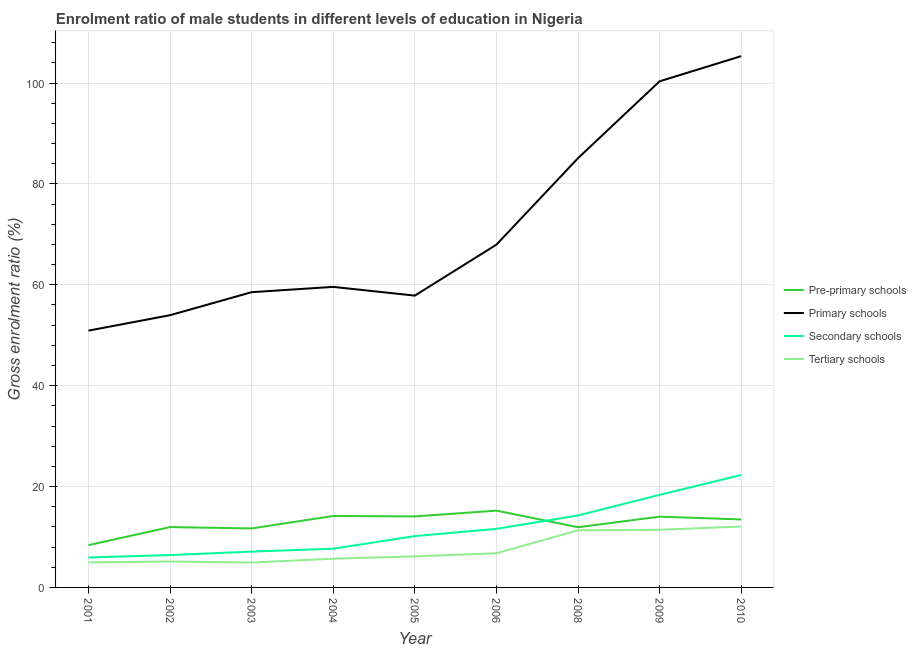Does the line corresponding to gross enrolment ratio(female) in tertiary schools intersect with the line corresponding to gross enrolment ratio(female) in secondary schools?
Make the answer very short. No. What is the gross enrolment ratio(female) in primary schools in 2005?
Offer a very short reply. 57.86. Across all years, what is the maximum gross enrolment ratio(female) in tertiary schools?
Keep it short and to the point. 12.07. Across all years, what is the minimum gross enrolment ratio(female) in primary schools?
Your answer should be compact. 50.92. In which year was the gross enrolment ratio(female) in secondary schools maximum?
Your response must be concise. 2010. In which year was the gross enrolment ratio(female) in primary schools minimum?
Provide a short and direct response. 2001. What is the total gross enrolment ratio(female) in pre-primary schools in the graph?
Offer a terse response. 114.98. What is the difference between the gross enrolment ratio(female) in tertiary schools in 2006 and that in 2008?
Provide a short and direct response. -4.55. What is the difference between the gross enrolment ratio(female) in primary schools in 2004 and the gross enrolment ratio(female) in pre-primary schools in 2009?
Keep it short and to the point. 45.55. What is the average gross enrolment ratio(female) in primary schools per year?
Your response must be concise. 71.07. In the year 2008, what is the difference between the gross enrolment ratio(female) in pre-primary schools and gross enrolment ratio(female) in tertiary schools?
Offer a terse response. 0.61. What is the ratio of the gross enrolment ratio(female) in secondary schools in 2003 to that in 2009?
Make the answer very short. 0.39. Is the difference between the gross enrolment ratio(female) in primary schools in 2002 and 2010 greater than the difference between the gross enrolment ratio(female) in pre-primary schools in 2002 and 2010?
Your answer should be compact. No. What is the difference between the highest and the second highest gross enrolment ratio(female) in primary schools?
Your answer should be very brief. 4.99. What is the difference between the highest and the lowest gross enrolment ratio(female) in primary schools?
Provide a succinct answer. 54.42. In how many years, is the gross enrolment ratio(female) in primary schools greater than the average gross enrolment ratio(female) in primary schools taken over all years?
Your response must be concise. 3. Is it the case that in every year, the sum of the gross enrolment ratio(female) in tertiary schools and gross enrolment ratio(female) in primary schools is greater than the sum of gross enrolment ratio(female) in secondary schools and gross enrolment ratio(female) in pre-primary schools?
Your answer should be very brief. Yes. Is it the case that in every year, the sum of the gross enrolment ratio(female) in pre-primary schools and gross enrolment ratio(female) in primary schools is greater than the gross enrolment ratio(female) in secondary schools?
Give a very brief answer. Yes. Does the gross enrolment ratio(female) in pre-primary schools monotonically increase over the years?
Provide a short and direct response. No. Is the gross enrolment ratio(female) in tertiary schools strictly less than the gross enrolment ratio(female) in secondary schools over the years?
Make the answer very short. Yes. What is the difference between two consecutive major ticks on the Y-axis?
Make the answer very short. 20. Does the graph contain any zero values?
Keep it short and to the point. No. What is the title of the graph?
Offer a very short reply. Enrolment ratio of male students in different levels of education in Nigeria. What is the Gross enrolment ratio (%) of Pre-primary schools in 2001?
Provide a succinct answer. 8.39. What is the Gross enrolment ratio (%) in Primary schools in 2001?
Make the answer very short. 50.92. What is the Gross enrolment ratio (%) in Secondary schools in 2001?
Provide a succinct answer. 5.94. What is the Gross enrolment ratio (%) in Tertiary schools in 2001?
Keep it short and to the point. 4.96. What is the Gross enrolment ratio (%) in Pre-primary schools in 2002?
Offer a terse response. 11.97. What is the Gross enrolment ratio (%) in Primary schools in 2002?
Keep it short and to the point. 53.98. What is the Gross enrolment ratio (%) in Secondary schools in 2002?
Give a very brief answer. 6.41. What is the Gross enrolment ratio (%) of Tertiary schools in 2002?
Provide a short and direct response. 5.14. What is the Gross enrolment ratio (%) of Pre-primary schools in 2003?
Provide a succinct answer. 11.7. What is the Gross enrolment ratio (%) of Primary schools in 2003?
Provide a short and direct response. 58.54. What is the Gross enrolment ratio (%) of Secondary schools in 2003?
Provide a succinct answer. 7.1. What is the Gross enrolment ratio (%) of Tertiary schools in 2003?
Keep it short and to the point. 4.93. What is the Gross enrolment ratio (%) of Pre-primary schools in 2004?
Your answer should be compact. 14.17. What is the Gross enrolment ratio (%) of Primary schools in 2004?
Your answer should be compact. 59.59. What is the Gross enrolment ratio (%) in Secondary schools in 2004?
Provide a succinct answer. 7.68. What is the Gross enrolment ratio (%) of Tertiary schools in 2004?
Give a very brief answer. 5.7. What is the Gross enrolment ratio (%) in Pre-primary schools in 2005?
Provide a succinct answer. 14.08. What is the Gross enrolment ratio (%) of Primary schools in 2005?
Your response must be concise. 57.86. What is the Gross enrolment ratio (%) in Secondary schools in 2005?
Offer a very short reply. 10.18. What is the Gross enrolment ratio (%) in Tertiary schools in 2005?
Keep it short and to the point. 6.16. What is the Gross enrolment ratio (%) of Pre-primary schools in 2006?
Your answer should be compact. 15.23. What is the Gross enrolment ratio (%) of Primary schools in 2006?
Provide a short and direct response. 67.96. What is the Gross enrolment ratio (%) of Secondary schools in 2006?
Ensure brevity in your answer.  11.61. What is the Gross enrolment ratio (%) of Tertiary schools in 2006?
Offer a very short reply. 6.78. What is the Gross enrolment ratio (%) of Pre-primary schools in 2008?
Your response must be concise. 11.94. What is the Gross enrolment ratio (%) of Primary schools in 2008?
Keep it short and to the point. 85.11. What is the Gross enrolment ratio (%) in Secondary schools in 2008?
Offer a terse response. 14.27. What is the Gross enrolment ratio (%) of Tertiary schools in 2008?
Provide a succinct answer. 11.32. What is the Gross enrolment ratio (%) in Pre-primary schools in 2009?
Your response must be concise. 14.04. What is the Gross enrolment ratio (%) in Primary schools in 2009?
Your response must be concise. 100.35. What is the Gross enrolment ratio (%) in Secondary schools in 2009?
Your answer should be compact. 18.35. What is the Gross enrolment ratio (%) of Tertiary schools in 2009?
Provide a short and direct response. 11.43. What is the Gross enrolment ratio (%) in Pre-primary schools in 2010?
Keep it short and to the point. 13.48. What is the Gross enrolment ratio (%) of Primary schools in 2010?
Provide a short and direct response. 105.34. What is the Gross enrolment ratio (%) of Secondary schools in 2010?
Your response must be concise. 22.3. What is the Gross enrolment ratio (%) of Tertiary schools in 2010?
Keep it short and to the point. 12.07. Across all years, what is the maximum Gross enrolment ratio (%) in Pre-primary schools?
Give a very brief answer. 15.23. Across all years, what is the maximum Gross enrolment ratio (%) of Primary schools?
Provide a short and direct response. 105.34. Across all years, what is the maximum Gross enrolment ratio (%) in Secondary schools?
Your response must be concise. 22.3. Across all years, what is the maximum Gross enrolment ratio (%) of Tertiary schools?
Give a very brief answer. 12.07. Across all years, what is the minimum Gross enrolment ratio (%) of Pre-primary schools?
Give a very brief answer. 8.39. Across all years, what is the minimum Gross enrolment ratio (%) in Primary schools?
Give a very brief answer. 50.92. Across all years, what is the minimum Gross enrolment ratio (%) of Secondary schools?
Offer a very short reply. 5.94. Across all years, what is the minimum Gross enrolment ratio (%) in Tertiary schools?
Give a very brief answer. 4.93. What is the total Gross enrolment ratio (%) of Pre-primary schools in the graph?
Your response must be concise. 114.98. What is the total Gross enrolment ratio (%) in Primary schools in the graph?
Your answer should be very brief. 639.64. What is the total Gross enrolment ratio (%) in Secondary schools in the graph?
Ensure brevity in your answer.  103.84. What is the total Gross enrolment ratio (%) of Tertiary schools in the graph?
Your answer should be compact. 68.5. What is the difference between the Gross enrolment ratio (%) of Pre-primary schools in 2001 and that in 2002?
Keep it short and to the point. -3.58. What is the difference between the Gross enrolment ratio (%) of Primary schools in 2001 and that in 2002?
Provide a succinct answer. -3.06. What is the difference between the Gross enrolment ratio (%) in Secondary schools in 2001 and that in 2002?
Keep it short and to the point. -0.48. What is the difference between the Gross enrolment ratio (%) in Tertiary schools in 2001 and that in 2002?
Provide a succinct answer. -0.18. What is the difference between the Gross enrolment ratio (%) of Pre-primary schools in 2001 and that in 2003?
Make the answer very short. -3.31. What is the difference between the Gross enrolment ratio (%) in Primary schools in 2001 and that in 2003?
Offer a terse response. -7.62. What is the difference between the Gross enrolment ratio (%) in Secondary schools in 2001 and that in 2003?
Provide a short and direct response. -1.17. What is the difference between the Gross enrolment ratio (%) in Tertiary schools in 2001 and that in 2003?
Give a very brief answer. 0.03. What is the difference between the Gross enrolment ratio (%) in Pre-primary schools in 2001 and that in 2004?
Ensure brevity in your answer.  -5.78. What is the difference between the Gross enrolment ratio (%) in Primary schools in 2001 and that in 2004?
Your answer should be compact. -8.67. What is the difference between the Gross enrolment ratio (%) in Secondary schools in 2001 and that in 2004?
Offer a very short reply. -1.74. What is the difference between the Gross enrolment ratio (%) in Tertiary schools in 2001 and that in 2004?
Provide a short and direct response. -0.73. What is the difference between the Gross enrolment ratio (%) of Pre-primary schools in 2001 and that in 2005?
Make the answer very short. -5.69. What is the difference between the Gross enrolment ratio (%) in Primary schools in 2001 and that in 2005?
Provide a succinct answer. -6.94. What is the difference between the Gross enrolment ratio (%) in Secondary schools in 2001 and that in 2005?
Your response must be concise. -4.24. What is the difference between the Gross enrolment ratio (%) of Tertiary schools in 2001 and that in 2005?
Give a very brief answer. -1.2. What is the difference between the Gross enrolment ratio (%) in Pre-primary schools in 2001 and that in 2006?
Your answer should be very brief. -6.84. What is the difference between the Gross enrolment ratio (%) in Primary schools in 2001 and that in 2006?
Make the answer very short. -17.04. What is the difference between the Gross enrolment ratio (%) of Secondary schools in 2001 and that in 2006?
Make the answer very short. -5.68. What is the difference between the Gross enrolment ratio (%) in Tertiary schools in 2001 and that in 2006?
Provide a succinct answer. -1.81. What is the difference between the Gross enrolment ratio (%) of Pre-primary schools in 2001 and that in 2008?
Give a very brief answer. -3.55. What is the difference between the Gross enrolment ratio (%) in Primary schools in 2001 and that in 2008?
Your response must be concise. -34.19. What is the difference between the Gross enrolment ratio (%) in Secondary schools in 2001 and that in 2008?
Make the answer very short. -8.33. What is the difference between the Gross enrolment ratio (%) in Tertiary schools in 2001 and that in 2008?
Your answer should be compact. -6.36. What is the difference between the Gross enrolment ratio (%) in Pre-primary schools in 2001 and that in 2009?
Your answer should be very brief. -5.65. What is the difference between the Gross enrolment ratio (%) in Primary schools in 2001 and that in 2009?
Your answer should be very brief. -49.43. What is the difference between the Gross enrolment ratio (%) in Secondary schools in 2001 and that in 2009?
Make the answer very short. -12.42. What is the difference between the Gross enrolment ratio (%) in Tertiary schools in 2001 and that in 2009?
Make the answer very short. -6.47. What is the difference between the Gross enrolment ratio (%) of Pre-primary schools in 2001 and that in 2010?
Give a very brief answer. -5.09. What is the difference between the Gross enrolment ratio (%) of Primary schools in 2001 and that in 2010?
Offer a terse response. -54.42. What is the difference between the Gross enrolment ratio (%) in Secondary schools in 2001 and that in 2010?
Your answer should be compact. -16.36. What is the difference between the Gross enrolment ratio (%) of Tertiary schools in 2001 and that in 2010?
Offer a very short reply. -7.11. What is the difference between the Gross enrolment ratio (%) of Pre-primary schools in 2002 and that in 2003?
Provide a succinct answer. 0.27. What is the difference between the Gross enrolment ratio (%) in Primary schools in 2002 and that in 2003?
Provide a short and direct response. -4.56. What is the difference between the Gross enrolment ratio (%) of Secondary schools in 2002 and that in 2003?
Provide a short and direct response. -0.69. What is the difference between the Gross enrolment ratio (%) of Tertiary schools in 2002 and that in 2003?
Provide a succinct answer. 0.21. What is the difference between the Gross enrolment ratio (%) in Pre-primary schools in 2002 and that in 2004?
Your response must be concise. -2.2. What is the difference between the Gross enrolment ratio (%) of Primary schools in 2002 and that in 2004?
Your answer should be compact. -5.61. What is the difference between the Gross enrolment ratio (%) in Secondary schools in 2002 and that in 2004?
Give a very brief answer. -1.26. What is the difference between the Gross enrolment ratio (%) of Tertiary schools in 2002 and that in 2004?
Keep it short and to the point. -0.55. What is the difference between the Gross enrolment ratio (%) in Pre-primary schools in 2002 and that in 2005?
Offer a terse response. -2.11. What is the difference between the Gross enrolment ratio (%) of Primary schools in 2002 and that in 2005?
Your response must be concise. -3.88. What is the difference between the Gross enrolment ratio (%) in Secondary schools in 2002 and that in 2005?
Keep it short and to the point. -3.77. What is the difference between the Gross enrolment ratio (%) of Tertiary schools in 2002 and that in 2005?
Offer a terse response. -1.02. What is the difference between the Gross enrolment ratio (%) in Pre-primary schools in 2002 and that in 2006?
Keep it short and to the point. -3.26. What is the difference between the Gross enrolment ratio (%) of Primary schools in 2002 and that in 2006?
Ensure brevity in your answer.  -13.98. What is the difference between the Gross enrolment ratio (%) of Secondary schools in 2002 and that in 2006?
Your answer should be very brief. -5.2. What is the difference between the Gross enrolment ratio (%) of Tertiary schools in 2002 and that in 2006?
Provide a short and direct response. -1.63. What is the difference between the Gross enrolment ratio (%) of Pre-primary schools in 2002 and that in 2008?
Make the answer very short. 0.03. What is the difference between the Gross enrolment ratio (%) of Primary schools in 2002 and that in 2008?
Provide a short and direct response. -31.13. What is the difference between the Gross enrolment ratio (%) in Secondary schools in 2002 and that in 2008?
Offer a very short reply. -7.85. What is the difference between the Gross enrolment ratio (%) in Tertiary schools in 2002 and that in 2008?
Make the answer very short. -6.18. What is the difference between the Gross enrolment ratio (%) in Pre-primary schools in 2002 and that in 2009?
Your response must be concise. -2.07. What is the difference between the Gross enrolment ratio (%) of Primary schools in 2002 and that in 2009?
Provide a short and direct response. -46.37. What is the difference between the Gross enrolment ratio (%) in Secondary schools in 2002 and that in 2009?
Your response must be concise. -11.94. What is the difference between the Gross enrolment ratio (%) of Tertiary schools in 2002 and that in 2009?
Offer a very short reply. -6.29. What is the difference between the Gross enrolment ratio (%) in Pre-primary schools in 2002 and that in 2010?
Your response must be concise. -1.51. What is the difference between the Gross enrolment ratio (%) in Primary schools in 2002 and that in 2010?
Keep it short and to the point. -51.36. What is the difference between the Gross enrolment ratio (%) in Secondary schools in 2002 and that in 2010?
Ensure brevity in your answer.  -15.88. What is the difference between the Gross enrolment ratio (%) in Tertiary schools in 2002 and that in 2010?
Provide a succinct answer. -6.93. What is the difference between the Gross enrolment ratio (%) of Pre-primary schools in 2003 and that in 2004?
Make the answer very short. -2.47. What is the difference between the Gross enrolment ratio (%) of Primary schools in 2003 and that in 2004?
Make the answer very short. -1.05. What is the difference between the Gross enrolment ratio (%) in Secondary schools in 2003 and that in 2004?
Your response must be concise. -0.57. What is the difference between the Gross enrolment ratio (%) of Tertiary schools in 2003 and that in 2004?
Your response must be concise. -0.77. What is the difference between the Gross enrolment ratio (%) of Pre-primary schools in 2003 and that in 2005?
Ensure brevity in your answer.  -2.38. What is the difference between the Gross enrolment ratio (%) in Primary schools in 2003 and that in 2005?
Provide a short and direct response. 0.68. What is the difference between the Gross enrolment ratio (%) in Secondary schools in 2003 and that in 2005?
Make the answer very short. -3.07. What is the difference between the Gross enrolment ratio (%) in Tertiary schools in 2003 and that in 2005?
Your answer should be compact. -1.23. What is the difference between the Gross enrolment ratio (%) in Pre-primary schools in 2003 and that in 2006?
Ensure brevity in your answer.  -3.53. What is the difference between the Gross enrolment ratio (%) in Primary schools in 2003 and that in 2006?
Give a very brief answer. -9.42. What is the difference between the Gross enrolment ratio (%) of Secondary schools in 2003 and that in 2006?
Offer a very short reply. -4.51. What is the difference between the Gross enrolment ratio (%) of Tertiary schools in 2003 and that in 2006?
Give a very brief answer. -1.84. What is the difference between the Gross enrolment ratio (%) of Pre-primary schools in 2003 and that in 2008?
Give a very brief answer. -0.24. What is the difference between the Gross enrolment ratio (%) in Primary schools in 2003 and that in 2008?
Your answer should be very brief. -26.57. What is the difference between the Gross enrolment ratio (%) of Secondary schools in 2003 and that in 2008?
Your answer should be very brief. -7.16. What is the difference between the Gross enrolment ratio (%) of Tertiary schools in 2003 and that in 2008?
Ensure brevity in your answer.  -6.39. What is the difference between the Gross enrolment ratio (%) of Pre-primary schools in 2003 and that in 2009?
Your answer should be compact. -2.34. What is the difference between the Gross enrolment ratio (%) in Primary schools in 2003 and that in 2009?
Your answer should be very brief. -41.81. What is the difference between the Gross enrolment ratio (%) of Secondary schools in 2003 and that in 2009?
Offer a terse response. -11.25. What is the difference between the Gross enrolment ratio (%) in Tertiary schools in 2003 and that in 2009?
Ensure brevity in your answer.  -6.5. What is the difference between the Gross enrolment ratio (%) in Pre-primary schools in 2003 and that in 2010?
Keep it short and to the point. -1.78. What is the difference between the Gross enrolment ratio (%) of Primary schools in 2003 and that in 2010?
Your answer should be very brief. -46.8. What is the difference between the Gross enrolment ratio (%) of Secondary schools in 2003 and that in 2010?
Offer a terse response. -15.19. What is the difference between the Gross enrolment ratio (%) in Tertiary schools in 2003 and that in 2010?
Give a very brief answer. -7.14. What is the difference between the Gross enrolment ratio (%) of Pre-primary schools in 2004 and that in 2005?
Provide a short and direct response. 0.09. What is the difference between the Gross enrolment ratio (%) of Primary schools in 2004 and that in 2005?
Your response must be concise. 1.73. What is the difference between the Gross enrolment ratio (%) of Secondary schools in 2004 and that in 2005?
Your answer should be very brief. -2.5. What is the difference between the Gross enrolment ratio (%) in Tertiary schools in 2004 and that in 2005?
Keep it short and to the point. -0.47. What is the difference between the Gross enrolment ratio (%) in Pre-primary schools in 2004 and that in 2006?
Keep it short and to the point. -1.06. What is the difference between the Gross enrolment ratio (%) of Primary schools in 2004 and that in 2006?
Give a very brief answer. -8.37. What is the difference between the Gross enrolment ratio (%) of Secondary schools in 2004 and that in 2006?
Ensure brevity in your answer.  -3.94. What is the difference between the Gross enrolment ratio (%) in Tertiary schools in 2004 and that in 2006?
Give a very brief answer. -1.08. What is the difference between the Gross enrolment ratio (%) of Pre-primary schools in 2004 and that in 2008?
Offer a terse response. 2.23. What is the difference between the Gross enrolment ratio (%) in Primary schools in 2004 and that in 2008?
Provide a short and direct response. -25.52. What is the difference between the Gross enrolment ratio (%) in Secondary schools in 2004 and that in 2008?
Ensure brevity in your answer.  -6.59. What is the difference between the Gross enrolment ratio (%) of Tertiary schools in 2004 and that in 2008?
Ensure brevity in your answer.  -5.63. What is the difference between the Gross enrolment ratio (%) in Pre-primary schools in 2004 and that in 2009?
Your response must be concise. 0.13. What is the difference between the Gross enrolment ratio (%) in Primary schools in 2004 and that in 2009?
Make the answer very short. -40.76. What is the difference between the Gross enrolment ratio (%) in Secondary schools in 2004 and that in 2009?
Make the answer very short. -10.68. What is the difference between the Gross enrolment ratio (%) of Tertiary schools in 2004 and that in 2009?
Your answer should be very brief. -5.74. What is the difference between the Gross enrolment ratio (%) of Pre-primary schools in 2004 and that in 2010?
Offer a very short reply. 0.69. What is the difference between the Gross enrolment ratio (%) of Primary schools in 2004 and that in 2010?
Provide a succinct answer. -45.75. What is the difference between the Gross enrolment ratio (%) in Secondary schools in 2004 and that in 2010?
Your answer should be compact. -14.62. What is the difference between the Gross enrolment ratio (%) in Tertiary schools in 2004 and that in 2010?
Give a very brief answer. -6.37. What is the difference between the Gross enrolment ratio (%) of Pre-primary schools in 2005 and that in 2006?
Keep it short and to the point. -1.15. What is the difference between the Gross enrolment ratio (%) in Primary schools in 2005 and that in 2006?
Offer a very short reply. -10.1. What is the difference between the Gross enrolment ratio (%) in Secondary schools in 2005 and that in 2006?
Your answer should be very brief. -1.44. What is the difference between the Gross enrolment ratio (%) of Tertiary schools in 2005 and that in 2006?
Ensure brevity in your answer.  -0.61. What is the difference between the Gross enrolment ratio (%) in Pre-primary schools in 2005 and that in 2008?
Offer a very short reply. 2.14. What is the difference between the Gross enrolment ratio (%) in Primary schools in 2005 and that in 2008?
Ensure brevity in your answer.  -27.25. What is the difference between the Gross enrolment ratio (%) of Secondary schools in 2005 and that in 2008?
Give a very brief answer. -4.09. What is the difference between the Gross enrolment ratio (%) in Tertiary schools in 2005 and that in 2008?
Your answer should be very brief. -5.16. What is the difference between the Gross enrolment ratio (%) in Pre-primary schools in 2005 and that in 2009?
Your response must be concise. 0.04. What is the difference between the Gross enrolment ratio (%) of Primary schools in 2005 and that in 2009?
Keep it short and to the point. -42.49. What is the difference between the Gross enrolment ratio (%) in Secondary schools in 2005 and that in 2009?
Offer a terse response. -8.17. What is the difference between the Gross enrolment ratio (%) in Tertiary schools in 2005 and that in 2009?
Provide a succinct answer. -5.27. What is the difference between the Gross enrolment ratio (%) of Pre-primary schools in 2005 and that in 2010?
Provide a short and direct response. 0.6. What is the difference between the Gross enrolment ratio (%) of Primary schools in 2005 and that in 2010?
Offer a very short reply. -47.48. What is the difference between the Gross enrolment ratio (%) in Secondary schools in 2005 and that in 2010?
Provide a short and direct response. -12.12. What is the difference between the Gross enrolment ratio (%) of Tertiary schools in 2005 and that in 2010?
Your response must be concise. -5.91. What is the difference between the Gross enrolment ratio (%) of Pre-primary schools in 2006 and that in 2008?
Your answer should be compact. 3.29. What is the difference between the Gross enrolment ratio (%) of Primary schools in 2006 and that in 2008?
Your answer should be compact. -17.15. What is the difference between the Gross enrolment ratio (%) of Secondary schools in 2006 and that in 2008?
Provide a succinct answer. -2.65. What is the difference between the Gross enrolment ratio (%) in Tertiary schools in 2006 and that in 2008?
Your response must be concise. -4.55. What is the difference between the Gross enrolment ratio (%) in Pre-primary schools in 2006 and that in 2009?
Provide a succinct answer. 1.19. What is the difference between the Gross enrolment ratio (%) of Primary schools in 2006 and that in 2009?
Ensure brevity in your answer.  -32.39. What is the difference between the Gross enrolment ratio (%) of Secondary schools in 2006 and that in 2009?
Your response must be concise. -6.74. What is the difference between the Gross enrolment ratio (%) in Tertiary schools in 2006 and that in 2009?
Give a very brief answer. -4.66. What is the difference between the Gross enrolment ratio (%) in Pre-primary schools in 2006 and that in 2010?
Your response must be concise. 1.75. What is the difference between the Gross enrolment ratio (%) of Primary schools in 2006 and that in 2010?
Offer a very short reply. -37.38. What is the difference between the Gross enrolment ratio (%) in Secondary schools in 2006 and that in 2010?
Ensure brevity in your answer.  -10.68. What is the difference between the Gross enrolment ratio (%) in Tertiary schools in 2006 and that in 2010?
Make the answer very short. -5.29. What is the difference between the Gross enrolment ratio (%) of Pre-primary schools in 2008 and that in 2009?
Your answer should be very brief. -2.1. What is the difference between the Gross enrolment ratio (%) in Primary schools in 2008 and that in 2009?
Provide a short and direct response. -15.24. What is the difference between the Gross enrolment ratio (%) of Secondary schools in 2008 and that in 2009?
Ensure brevity in your answer.  -4.09. What is the difference between the Gross enrolment ratio (%) of Tertiary schools in 2008 and that in 2009?
Ensure brevity in your answer.  -0.11. What is the difference between the Gross enrolment ratio (%) of Pre-primary schools in 2008 and that in 2010?
Offer a very short reply. -1.54. What is the difference between the Gross enrolment ratio (%) of Primary schools in 2008 and that in 2010?
Offer a terse response. -20.23. What is the difference between the Gross enrolment ratio (%) of Secondary schools in 2008 and that in 2010?
Keep it short and to the point. -8.03. What is the difference between the Gross enrolment ratio (%) of Tertiary schools in 2008 and that in 2010?
Provide a succinct answer. -0.75. What is the difference between the Gross enrolment ratio (%) of Pre-primary schools in 2009 and that in 2010?
Your answer should be compact. 0.56. What is the difference between the Gross enrolment ratio (%) of Primary schools in 2009 and that in 2010?
Provide a short and direct response. -4.99. What is the difference between the Gross enrolment ratio (%) of Secondary schools in 2009 and that in 2010?
Your answer should be very brief. -3.94. What is the difference between the Gross enrolment ratio (%) in Tertiary schools in 2009 and that in 2010?
Your response must be concise. -0.64. What is the difference between the Gross enrolment ratio (%) in Pre-primary schools in 2001 and the Gross enrolment ratio (%) in Primary schools in 2002?
Make the answer very short. -45.59. What is the difference between the Gross enrolment ratio (%) in Pre-primary schools in 2001 and the Gross enrolment ratio (%) in Secondary schools in 2002?
Ensure brevity in your answer.  1.98. What is the difference between the Gross enrolment ratio (%) in Pre-primary schools in 2001 and the Gross enrolment ratio (%) in Tertiary schools in 2002?
Your answer should be very brief. 3.25. What is the difference between the Gross enrolment ratio (%) in Primary schools in 2001 and the Gross enrolment ratio (%) in Secondary schools in 2002?
Ensure brevity in your answer.  44.5. What is the difference between the Gross enrolment ratio (%) of Primary schools in 2001 and the Gross enrolment ratio (%) of Tertiary schools in 2002?
Give a very brief answer. 45.77. What is the difference between the Gross enrolment ratio (%) in Secondary schools in 2001 and the Gross enrolment ratio (%) in Tertiary schools in 2002?
Your response must be concise. 0.79. What is the difference between the Gross enrolment ratio (%) in Pre-primary schools in 2001 and the Gross enrolment ratio (%) in Primary schools in 2003?
Keep it short and to the point. -50.15. What is the difference between the Gross enrolment ratio (%) of Pre-primary schools in 2001 and the Gross enrolment ratio (%) of Secondary schools in 2003?
Keep it short and to the point. 1.29. What is the difference between the Gross enrolment ratio (%) in Pre-primary schools in 2001 and the Gross enrolment ratio (%) in Tertiary schools in 2003?
Keep it short and to the point. 3.46. What is the difference between the Gross enrolment ratio (%) in Primary schools in 2001 and the Gross enrolment ratio (%) in Secondary schools in 2003?
Offer a very short reply. 43.81. What is the difference between the Gross enrolment ratio (%) in Primary schools in 2001 and the Gross enrolment ratio (%) in Tertiary schools in 2003?
Make the answer very short. 45.99. What is the difference between the Gross enrolment ratio (%) in Pre-primary schools in 2001 and the Gross enrolment ratio (%) in Primary schools in 2004?
Give a very brief answer. -51.2. What is the difference between the Gross enrolment ratio (%) of Pre-primary schools in 2001 and the Gross enrolment ratio (%) of Secondary schools in 2004?
Offer a very short reply. 0.71. What is the difference between the Gross enrolment ratio (%) of Pre-primary schools in 2001 and the Gross enrolment ratio (%) of Tertiary schools in 2004?
Give a very brief answer. 2.69. What is the difference between the Gross enrolment ratio (%) in Primary schools in 2001 and the Gross enrolment ratio (%) in Secondary schools in 2004?
Your answer should be compact. 43.24. What is the difference between the Gross enrolment ratio (%) of Primary schools in 2001 and the Gross enrolment ratio (%) of Tertiary schools in 2004?
Ensure brevity in your answer.  45.22. What is the difference between the Gross enrolment ratio (%) of Secondary schools in 2001 and the Gross enrolment ratio (%) of Tertiary schools in 2004?
Your response must be concise. 0.24. What is the difference between the Gross enrolment ratio (%) in Pre-primary schools in 2001 and the Gross enrolment ratio (%) in Primary schools in 2005?
Provide a succinct answer. -49.47. What is the difference between the Gross enrolment ratio (%) in Pre-primary schools in 2001 and the Gross enrolment ratio (%) in Secondary schools in 2005?
Your response must be concise. -1.79. What is the difference between the Gross enrolment ratio (%) of Pre-primary schools in 2001 and the Gross enrolment ratio (%) of Tertiary schools in 2005?
Your answer should be very brief. 2.23. What is the difference between the Gross enrolment ratio (%) in Primary schools in 2001 and the Gross enrolment ratio (%) in Secondary schools in 2005?
Keep it short and to the point. 40.74. What is the difference between the Gross enrolment ratio (%) in Primary schools in 2001 and the Gross enrolment ratio (%) in Tertiary schools in 2005?
Your answer should be compact. 44.75. What is the difference between the Gross enrolment ratio (%) of Secondary schools in 2001 and the Gross enrolment ratio (%) of Tertiary schools in 2005?
Provide a short and direct response. -0.23. What is the difference between the Gross enrolment ratio (%) in Pre-primary schools in 2001 and the Gross enrolment ratio (%) in Primary schools in 2006?
Your answer should be very brief. -59.57. What is the difference between the Gross enrolment ratio (%) of Pre-primary schools in 2001 and the Gross enrolment ratio (%) of Secondary schools in 2006?
Make the answer very short. -3.22. What is the difference between the Gross enrolment ratio (%) of Pre-primary schools in 2001 and the Gross enrolment ratio (%) of Tertiary schools in 2006?
Provide a succinct answer. 1.61. What is the difference between the Gross enrolment ratio (%) of Primary schools in 2001 and the Gross enrolment ratio (%) of Secondary schools in 2006?
Keep it short and to the point. 39.3. What is the difference between the Gross enrolment ratio (%) of Primary schools in 2001 and the Gross enrolment ratio (%) of Tertiary schools in 2006?
Provide a short and direct response. 44.14. What is the difference between the Gross enrolment ratio (%) of Secondary schools in 2001 and the Gross enrolment ratio (%) of Tertiary schools in 2006?
Give a very brief answer. -0.84. What is the difference between the Gross enrolment ratio (%) of Pre-primary schools in 2001 and the Gross enrolment ratio (%) of Primary schools in 2008?
Your answer should be compact. -76.72. What is the difference between the Gross enrolment ratio (%) of Pre-primary schools in 2001 and the Gross enrolment ratio (%) of Secondary schools in 2008?
Your answer should be compact. -5.88. What is the difference between the Gross enrolment ratio (%) in Pre-primary schools in 2001 and the Gross enrolment ratio (%) in Tertiary schools in 2008?
Offer a very short reply. -2.93. What is the difference between the Gross enrolment ratio (%) in Primary schools in 2001 and the Gross enrolment ratio (%) in Secondary schools in 2008?
Offer a very short reply. 36.65. What is the difference between the Gross enrolment ratio (%) in Primary schools in 2001 and the Gross enrolment ratio (%) in Tertiary schools in 2008?
Offer a very short reply. 39.59. What is the difference between the Gross enrolment ratio (%) of Secondary schools in 2001 and the Gross enrolment ratio (%) of Tertiary schools in 2008?
Keep it short and to the point. -5.39. What is the difference between the Gross enrolment ratio (%) in Pre-primary schools in 2001 and the Gross enrolment ratio (%) in Primary schools in 2009?
Offer a terse response. -91.96. What is the difference between the Gross enrolment ratio (%) of Pre-primary schools in 2001 and the Gross enrolment ratio (%) of Secondary schools in 2009?
Your response must be concise. -9.96. What is the difference between the Gross enrolment ratio (%) in Pre-primary schools in 2001 and the Gross enrolment ratio (%) in Tertiary schools in 2009?
Ensure brevity in your answer.  -3.04. What is the difference between the Gross enrolment ratio (%) of Primary schools in 2001 and the Gross enrolment ratio (%) of Secondary schools in 2009?
Offer a terse response. 32.56. What is the difference between the Gross enrolment ratio (%) in Primary schools in 2001 and the Gross enrolment ratio (%) in Tertiary schools in 2009?
Make the answer very short. 39.48. What is the difference between the Gross enrolment ratio (%) of Secondary schools in 2001 and the Gross enrolment ratio (%) of Tertiary schools in 2009?
Keep it short and to the point. -5.5. What is the difference between the Gross enrolment ratio (%) of Pre-primary schools in 2001 and the Gross enrolment ratio (%) of Primary schools in 2010?
Your response must be concise. -96.95. What is the difference between the Gross enrolment ratio (%) in Pre-primary schools in 2001 and the Gross enrolment ratio (%) in Secondary schools in 2010?
Provide a short and direct response. -13.91. What is the difference between the Gross enrolment ratio (%) of Pre-primary schools in 2001 and the Gross enrolment ratio (%) of Tertiary schools in 2010?
Give a very brief answer. -3.68. What is the difference between the Gross enrolment ratio (%) in Primary schools in 2001 and the Gross enrolment ratio (%) in Secondary schools in 2010?
Offer a terse response. 28.62. What is the difference between the Gross enrolment ratio (%) of Primary schools in 2001 and the Gross enrolment ratio (%) of Tertiary schools in 2010?
Your answer should be very brief. 38.85. What is the difference between the Gross enrolment ratio (%) of Secondary schools in 2001 and the Gross enrolment ratio (%) of Tertiary schools in 2010?
Your answer should be compact. -6.13. What is the difference between the Gross enrolment ratio (%) in Pre-primary schools in 2002 and the Gross enrolment ratio (%) in Primary schools in 2003?
Ensure brevity in your answer.  -46.58. What is the difference between the Gross enrolment ratio (%) of Pre-primary schools in 2002 and the Gross enrolment ratio (%) of Secondary schools in 2003?
Your answer should be very brief. 4.86. What is the difference between the Gross enrolment ratio (%) in Pre-primary schools in 2002 and the Gross enrolment ratio (%) in Tertiary schools in 2003?
Your answer should be very brief. 7.03. What is the difference between the Gross enrolment ratio (%) in Primary schools in 2002 and the Gross enrolment ratio (%) in Secondary schools in 2003?
Keep it short and to the point. 46.87. What is the difference between the Gross enrolment ratio (%) in Primary schools in 2002 and the Gross enrolment ratio (%) in Tertiary schools in 2003?
Make the answer very short. 49.05. What is the difference between the Gross enrolment ratio (%) of Secondary schools in 2002 and the Gross enrolment ratio (%) of Tertiary schools in 2003?
Your response must be concise. 1.48. What is the difference between the Gross enrolment ratio (%) of Pre-primary schools in 2002 and the Gross enrolment ratio (%) of Primary schools in 2004?
Keep it short and to the point. -47.62. What is the difference between the Gross enrolment ratio (%) of Pre-primary schools in 2002 and the Gross enrolment ratio (%) of Secondary schools in 2004?
Make the answer very short. 4.29. What is the difference between the Gross enrolment ratio (%) in Pre-primary schools in 2002 and the Gross enrolment ratio (%) in Tertiary schools in 2004?
Your answer should be compact. 6.27. What is the difference between the Gross enrolment ratio (%) of Primary schools in 2002 and the Gross enrolment ratio (%) of Secondary schools in 2004?
Keep it short and to the point. 46.3. What is the difference between the Gross enrolment ratio (%) of Primary schools in 2002 and the Gross enrolment ratio (%) of Tertiary schools in 2004?
Make the answer very short. 48.28. What is the difference between the Gross enrolment ratio (%) of Secondary schools in 2002 and the Gross enrolment ratio (%) of Tertiary schools in 2004?
Offer a terse response. 0.72. What is the difference between the Gross enrolment ratio (%) of Pre-primary schools in 2002 and the Gross enrolment ratio (%) of Primary schools in 2005?
Your answer should be very brief. -45.89. What is the difference between the Gross enrolment ratio (%) in Pre-primary schools in 2002 and the Gross enrolment ratio (%) in Secondary schools in 2005?
Your answer should be compact. 1.79. What is the difference between the Gross enrolment ratio (%) of Pre-primary schools in 2002 and the Gross enrolment ratio (%) of Tertiary schools in 2005?
Keep it short and to the point. 5.8. What is the difference between the Gross enrolment ratio (%) of Primary schools in 2002 and the Gross enrolment ratio (%) of Secondary schools in 2005?
Keep it short and to the point. 43.8. What is the difference between the Gross enrolment ratio (%) in Primary schools in 2002 and the Gross enrolment ratio (%) in Tertiary schools in 2005?
Provide a short and direct response. 47.81. What is the difference between the Gross enrolment ratio (%) in Secondary schools in 2002 and the Gross enrolment ratio (%) in Tertiary schools in 2005?
Keep it short and to the point. 0.25. What is the difference between the Gross enrolment ratio (%) in Pre-primary schools in 2002 and the Gross enrolment ratio (%) in Primary schools in 2006?
Offer a terse response. -56. What is the difference between the Gross enrolment ratio (%) of Pre-primary schools in 2002 and the Gross enrolment ratio (%) of Secondary schools in 2006?
Your answer should be compact. 0.35. What is the difference between the Gross enrolment ratio (%) of Pre-primary schools in 2002 and the Gross enrolment ratio (%) of Tertiary schools in 2006?
Provide a short and direct response. 5.19. What is the difference between the Gross enrolment ratio (%) of Primary schools in 2002 and the Gross enrolment ratio (%) of Secondary schools in 2006?
Keep it short and to the point. 42.36. What is the difference between the Gross enrolment ratio (%) of Primary schools in 2002 and the Gross enrolment ratio (%) of Tertiary schools in 2006?
Ensure brevity in your answer.  47.2. What is the difference between the Gross enrolment ratio (%) of Secondary schools in 2002 and the Gross enrolment ratio (%) of Tertiary schools in 2006?
Provide a short and direct response. -0.36. What is the difference between the Gross enrolment ratio (%) of Pre-primary schools in 2002 and the Gross enrolment ratio (%) of Primary schools in 2008?
Keep it short and to the point. -73.14. What is the difference between the Gross enrolment ratio (%) in Pre-primary schools in 2002 and the Gross enrolment ratio (%) in Secondary schools in 2008?
Give a very brief answer. -2.3. What is the difference between the Gross enrolment ratio (%) in Pre-primary schools in 2002 and the Gross enrolment ratio (%) in Tertiary schools in 2008?
Offer a terse response. 0.64. What is the difference between the Gross enrolment ratio (%) of Primary schools in 2002 and the Gross enrolment ratio (%) of Secondary schools in 2008?
Your response must be concise. 39.71. What is the difference between the Gross enrolment ratio (%) in Primary schools in 2002 and the Gross enrolment ratio (%) in Tertiary schools in 2008?
Provide a short and direct response. 42.65. What is the difference between the Gross enrolment ratio (%) of Secondary schools in 2002 and the Gross enrolment ratio (%) of Tertiary schools in 2008?
Offer a very short reply. -4.91. What is the difference between the Gross enrolment ratio (%) of Pre-primary schools in 2002 and the Gross enrolment ratio (%) of Primary schools in 2009?
Keep it short and to the point. -88.38. What is the difference between the Gross enrolment ratio (%) of Pre-primary schools in 2002 and the Gross enrolment ratio (%) of Secondary schools in 2009?
Ensure brevity in your answer.  -6.39. What is the difference between the Gross enrolment ratio (%) in Pre-primary schools in 2002 and the Gross enrolment ratio (%) in Tertiary schools in 2009?
Your answer should be compact. 0.53. What is the difference between the Gross enrolment ratio (%) of Primary schools in 2002 and the Gross enrolment ratio (%) of Secondary schools in 2009?
Your answer should be very brief. 35.62. What is the difference between the Gross enrolment ratio (%) of Primary schools in 2002 and the Gross enrolment ratio (%) of Tertiary schools in 2009?
Give a very brief answer. 42.54. What is the difference between the Gross enrolment ratio (%) in Secondary schools in 2002 and the Gross enrolment ratio (%) in Tertiary schools in 2009?
Keep it short and to the point. -5.02. What is the difference between the Gross enrolment ratio (%) of Pre-primary schools in 2002 and the Gross enrolment ratio (%) of Primary schools in 2010?
Your answer should be very brief. -93.37. What is the difference between the Gross enrolment ratio (%) in Pre-primary schools in 2002 and the Gross enrolment ratio (%) in Secondary schools in 2010?
Make the answer very short. -10.33. What is the difference between the Gross enrolment ratio (%) of Pre-primary schools in 2002 and the Gross enrolment ratio (%) of Tertiary schools in 2010?
Give a very brief answer. -0.1. What is the difference between the Gross enrolment ratio (%) of Primary schools in 2002 and the Gross enrolment ratio (%) of Secondary schools in 2010?
Keep it short and to the point. 31.68. What is the difference between the Gross enrolment ratio (%) of Primary schools in 2002 and the Gross enrolment ratio (%) of Tertiary schools in 2010?
Offer a very short reply. 41.91. What is the difference between the Gross enrolment ratio (%) in Secondary schools in 2002 and the Gross enrolment ratio (%) in Tertiary schools in 2010?
Give a very brief answer. -5.66. What is the difference between the Gross enrolment ratio (%) of Pre-primary schools in 2003 and the Gross enrolment ratio (%) of Primary schools in 2004?
Your answer should be compact. -47.89. What is the difference between the Gross enrolment ratio (%) in Pre-primary schools in 2003 and the Gross enrolment ratio (%) in Secondary schools in 2004?
Provide a succinct answer. 4.02. What is the difference between the Gross enrolment ratio (%) in Pre-primary schools in 2003 and the Gross enrolment ratio (%) in Tertiary schools in 2004?
Provide a succinct answer. 6. What is the difference between the Gross enrolment ratio (%) in Primary schools in 2003 and the Gross enrolment ratio (%) in Secondary schools in 2004?
Your answer should be compact. 50.86. What is the difference between the Gross enrolment ratio (%) in Primary schools in 2003 and the Gross enrolment ratio (%) in Tertiary schools in 2004?
Your response must be concise. 52.84. What is the difference between the Gross enrolment ratio (%) of Secondary schools in 2003 and the Gross enrolment ratio (%) of Tertiary schools in 2004?
Keep it short and to the point. 1.41. What is the difference between the Gross enrolment ratio (%) of Pre-primary schools in 2003 and the Gross enrolment ratio (%) of Primary schools in 2005?
Offer a very short reply. -46.16. What is the difference between the Gross enrolment ratio (%) of Pre-primary schools in 2003 and the Gross enrolment ratio (%) of Secondary schools in 2005?
Offer a terse response. 1.52. What is the difference between the Gross enrolment ratio (%) in Pre-primary schools in 2003 and the Gross enrolment ratio (%) in Tertiary schools in 2005?
Your answer should be compact. 5.54. What is the difference between the Gross enrolment ratio (%) in Primary schools in 2003 and the Gross enrolment ratio (%) in Secondary schools in 2005?
Keep it short and to the point. 48.36. What is the difference between the Gross enrolment ratio (%) of Primary schools in 2003 and the Gross enrolment ratio (%) of Tertiary schools in 2005?
Offer a very short reply. 52.38. What is the difference between the Gross enrolment ratio (%) in Secondary schools in 2003 and the Gross enrolment ratio (%) in Tertiary schools in 2005?
Keep it short and to the point. 0.94. What is the difference between the Gross enrolment ratio (%) of Pre-primary schools in 2003 and the Gross enrolment ratio (%) of Primary schools in 2006?
Make the answer very short. -56.26. What is the difference between the Gross enrolment ratio (%) in Pre-primary schools in 2003 and the Gross enrolment ratio (%) in Secondary schools in 2006?
Offer a very short reply. 0.09. What is the difference between the Gross enrolment ratio (%) of Pre-primary schools in 2003 and the Gross enrolment ratio (%) of Tertiary schools in 2006?
Your response must be concise. 4.92. What is the difference between the Gross enrolment ratio (%) in Primary schools in 2003 and the Gross enrolment ratio (%) in Secondary schools in 2006?
Offer a terse response. 46.93. What is the difference between the Gross enrolment ratio (%) in Primary schools in 2003 and the Gross enrolment ratio (%) in Tertiary schools in 2006?
Your answer should be compact. 51.77. What is the difference between the Gross enrolment ratio (%) in Secondary schools in 2003 and the Gross enrolment ratio (%) in Tertiary schools in 2006?
Offer a terse response. 0.33. What is the difference between the Gross enrolment ratio (%) in Pre-primary schools in 2003 and the Gross enrolment ratio (%) in Primary schools in 2008?
Your answer should be compact. -73.41. What is the difference between the Gross enrolment ratio (%) in Pre-primary schools in 2003 and the Gross enrolment ratio (%) in Secondary schools in 2008?
Your answer should be very brief. -2.57. What is the difference between the Gross enrolment ratio (%) of Pre-primary schools in 2003 and the Gross enrolment ratio (%) of Tertiary schools in 2008?
Your answer should be very brief. 0.38. What is the difference between the Gross enrolment ratio (%) in Primary schools in 2003 and the Gross enrolment ratio (%) in Secondary schools in 2008?
Give a very brief answer. 44.27. What is the difference between the Gross enrolment ratio (%) of Primary schools in 2003 and the Gross enrolment ratio (%) of Tertiary schools in 2008?
Offer a very short reply. 47.22. What is the difference between the Gross enrolment ratio (%) of Secondary schools in 2003 and the Gross enrolment ratio (%) of Tertiary schools in 2008?
Your answer should be compact. -4.22. What is the difference between the Gross enrolment ratio (%) in Pre-primary schools in 2003 and the Gross enrolment ratio (%) in Primary schools in 2009?
Give a very brief answer. -88.65. What is the difference between the Gross enrolment ratio (%) of Pre-primary schools in 2003 and the Gross enrolment ratio (%) of Secondary schools in 2009?
Give a very brief answer. -6.65. What is the difference between the Gross enrolment ratio (%) in Pre-primary schools in 2003 and the Gross enrolment ratio (%) in Tertiary schools in 2009?
Offer a very short reply. 0.27. What is the difference between the Gross enrolment ratio (%) in Primary schools in 2003 and the Gross enrolment ratio (%) in Secondary schools in 2009?
Your answer should be very brief. 40.19. What is the difference between the Gross enrolment ratio (%) in Primary schools in 2003 and the Gross enrolment ratio (%) in Tertiary schools in 2009?
Give a very brief answer. 47.11. What is the difference between the Gross enrolment ratio (%) of Secondary schools in 2003 and the Gross enrolment ratio (%) of Tertiary schools in 2009?
Give a very brief answer. -4.33. What is the difference between the Gross enrolment ratio (%) in Pre-primary schools in 2003 and the Gross enrolment ratio (%) in Primary schools in 2010?
Give a very brief answer. -93.64. What is the difference between the Gross enrolment ratio (%) of Pre-primary schools in 2003 and the Gross enrolment ratio (%) of Secondary schools in 2010?
Your answer should be very brief. -10.6. What is the difference between the Gross enrolment ratio (%) in Pre-primary schools in 2003 and the Gross enrolment ratio (%) in Tertiary schools in 2010?
Your response must be concise. -0.37. What is the difference between the Gross enrolment ratio (%) of Primary schools in 2003 and the Gross enrolment ratio (%) of Secondary schools in 2010?
Make the answer very short. 36.25. What is the difference between the Gross enrolment ratio (%) in Primary schools in 2003 and the Gross enrolment ratio (%) in Tertiary schools in 2010?
Offer a terse response. 46.47. What is the difference between the Gross enrolment ratio (%) in Secondary schools in 2003 and the Gross enrolment ratio (%) in Tertiary schools in 2010?
Ensure brevity in your answer.  -4.97. What is the difference between the Gross enrolment ratio (%) of Pre-primary schools in 2004 and the Gross enrolment ratio (%) of Primary schools in 2005?
Provide a short and direct response. -43.69. What is the difference between the Gross enrolment ratio (%) of Pre-primary schools in 2004 and the Gross enrolment ratio (%) of Secondary schools in 2005?
Ensure brevity in your answer.  3.99. What is the difference between the Gross enrolment ratio (%) of Pre-primary schools in 2004 and the Gross enrolment ratio (%) of Tertiary schools in 2005?
Offer a terse response. 8. What is the difference between the Gross enrolment ratio (%) in Primary schools in 2004 and the Gross enrolment ratio (%) in Secondary schools in 2005?
Give a very brief answer. 49.41. What is the difference between the Gross enrolment ratio (%) of Primary schools in 2004 and the Gross enrolment ratio (%) of Tertiary schools in 2005?
Provide a succinct answer. 53.42. What is the difference between the Gross enrolment ratio (%) of Secondary schools in 2004 and the Gross enrolment ratio (%) of Tertiary schools in 2005?
Ensure brevity in your answer.  1.51. What is the difference between the Gross enrolment ratio (%) of Pre-primary schools in 2004 and the Gross enrolment ratio (%) of Primary schools in 2006?
Keep it short and to the point. -53.8. What is the difference between the Gross enrolment ratio (%) in Pre-primary schools in 2004 and the Gross enrolment ratio (%) in Secondary schools in 2006?
Give a very brief answer. 2.55. What is the difference between the Gross enrolment ratio (%) of Pre-primary schools in 2004 and the Gross enrolment ratio (%) of Tertiary schools in 2006?
Provide a short and direct response. 7.39. What is the difference between the Gross enrolment ratio (%) in Primary schools in 2004 and the Gross enrolment ratio (%) in Secondary schools in 2006?
Offer a very short reply. 47.97. What is the difference between the Gross enrolment ratio (%) in Primary schools in 2004 and the Gross enrolment ratio (%) in Tertiary schools in 2006?
Your answer should be very brief. 52.81. What is the difference between the Gross enrolment ratio (%) of Secondary schools in 2004 and the Gross enrolment ratio (%) of Tertiary schools in 2006?
Provide a succinct answer. 0.9. What is the difference between the Gross enrolment ratio (%) in Pre-primary schools in 2004 and the Gross enrolment ratio (%) in Primary schools in 2008?
Ensure brevity in your answer.  -70.94. What is the difference between the Gross enrolment ratio (%) of Pre-primary schools in 2004 and the Gross enrolment ratio (%) of Secondary schools in 2008?
Your answer should be very brief. -0.1. What is the difference between the Gross enrolment ratio (%) in Pre-primary schools in 2004 and the Gross enrolment ratio (%) in Tertiary schools in 2008?
Your answer should be compact. 2.84. What is the difference between the Gross enrolment ratio (%) in Primary schools in 2004 and the Gross enrolment ratio (%) in Secondary schools in 2008?
Provide a succinct answer. 45.32. What is the difference between the Gross enrolment ratio (%) of Primary schools in 2004 and the Gross enrolment ratio (%) of Tertiary schools in 2008?
Your response must be concise. 48.26. What is the difference between the Gross enrolment ratio (%) of Secondary schools in 2004 and the Gross enrolment ratio (%) of Tertiary schools in 2008?
Give a very brief answer. -3.65. What is the difference between the Gross enrolment ratio (%) of Pre-primary schools in 2004 and the Gross enrolment ratio (%) of Primary schools in 2009?
Make the answer very short. -86.18. What is the difference between the Gross enrolment ratio (%) of Pre-primary schools in 2004 and the Gross enrolment ratio (%) of Secondary schools in 2009?
Keep it short and to the point. -4.19. What is the difference between the Gross enrolment ratio (%) of Pre-primary schools in 2004 and the Gross enrolment ratio (%) of Tertiary schools in 2009?
Keep it short and to the point. 2.73. What is the difference between the Gross enrolment ratio (%) of Primary schools in 2004 and the Gross enrolment ratio (%) of Secondary schools in 2009?
Offer a very short reply. 41.24. What is the difference between the Gross enrolment ratio (%) of Primary schools in 2004 and the Gross enrolment ratio (%) of Tertiary schools in 2009?
Keep it short and to the point. 48.16. What is the difference between the Gross enrolment ratio (%) in Secondary schools in 2004 and the Gross enrolment ratio (%) in Tertiary schools in 2009?
Your answer should be very brief. -3.76. What is the difference between the Gross enrolment ratio (%) of Pre-primary schools in 2004 and the Gross enrolment ratio (%) of Primary schools in 2010?
Your response must be concise. -91.17. What is the difference between the Gross enrolment ratio (%) in Pre-primary schools in 2004 and the Gross enrolment ratio (%) in Secondary schools in 2010?
Keep it short and to the point. -8.13. What is the difference between the Gross enrolment ratio (%) of Pre-primary schools in 2004 and the Gross enrolment ratio (%) of Tertiary schools in 2010?
Make the answer very short. 2.1. What is the difference between the Gross enrolment ratio (%) of Primary schools in 2004 and the Gross enrolment ratio (%) of Secondary schools in 2010?
Make the answer very short. 37.29. What is the difference between the Gross enrolment ratio (%) of Primary schools in 2004 and the Gross enrolment ratio (%) of Tertiary schools in 2010?
Keep it short and to the point. 47.52. What is the difference between the Gross enrolment ratio (%) in Secondary schools in 2004 and the Gross enrolment ratio (%) in Tertiary schools in 2010?
Give a very brief answer. -4.39. What is the difference between the Gross enrolment ratio (%) of Pre-primary schools in 2005 and the Gross enrolment ratio (%) of Primary schools in 2006?
Give a very brief answer. -53.88. What is the difference between the Gross enrolment ratio (%) of Pre-primary schools in 2005 and the Gross enrolment ratio (%) of Secondary schools in 2006?
Your answer should be compact. 2.46. What is the difference between the Gross enrolment ratio (%) in Pre-primary schools in 2005 and the Gross enrolment ratio (%) in Tertiary schools in 2006?
Your answer should be compact. 7.3. What is the difference between the Gross enrolment ratio (%) of Primary schools in 2005 and the Gross enrolment ratio (%) of Secondary schools in 2006?
Your answer should be compact. 46.25. What is the difference between the Gross enrolment ratio (%) of Primary schools in 2005 and the Gross enrolment ratio (%) of Tertiary schools in 2006?
Offer a very short reply. 51.08. What is the difference between the Gross enrolment ratio (%) in Secondary schools in 2005 and the Gross enrolment ratio (%) in Tertiary schools in 2006?
Give a very brief answer. 3.4. What is the difference between the Gross enrolment ratio (%) in Pre-primary schools in 2005 and the Gross enrolment ratio (%) in Primary schools in 2008?
Your answer should be compact. -71.03. What is the difference between the Gross enrolment ratio (%) in Pre-primary schools in 2005 and the Gross enrolment ratio (%) in Secondary schools in 2008?
Provide a succinct answer. -0.19. What is the difference between the Gross enrolment ratio (%) of Pre-primary schools in 2005 and the Gross enrolment ratio (%) of Tertiary schools in 2008?
Provide a short and direct response. 2.75. What is the difference between the Gross enrolment ratio (%) in Primary schools in 2005 and the Gross enrolment ratio (%) in Secondary schools in 2008?
Make the answer very short. 43.59. What is the difference between the Gross enrolment ratio (%) of Primary schools in 2005 and the Gross enrolment ratio (%) of Tertiary schools in 2008?
Ensure brevity in your answer.  46.54. What is the difference between the Gross enrolment ratio (%) of Secondary schools in 2005 and the Gross enrolment ratio (%) of Tertiary schools in 2008?
Keep it short and to the point. -1.15. What is the difference between the Gross enrolment ratio (%) in Pre-primary schools in 2005 and the Gross enrolment ratio (%) in Primary schools in 2009?
Ensure brevity in your answer.  -86.27. What is the difference between the Gross enrolment ratio (%) in Pre-primary schools in 2005 and the Gross enrolment ratio (%) in Secondary schools in 2009?
Make the answer very short. -4.27. What is the difference between the Gross enrolment ratio (%) of Pre-primary schools in 2005 and the Gross enrolment ratio (%) of Tertiary schools in 2009?
Your answer should be very brief. 2.65. What is the difference between the Gross enrolment ratio (%) of Primary schools in 2005 and the Gross enrolment ratio (%) of Secondary schools in 2009?
Your response must be concise. 39.51. What is the difference between the Gross enrolment ratio (%) in Primary schools in 2005 and the Gross enrolment ratio (%) in Tertiary schools in 2009?
Your answer should be very brief. 46.43. What is the difference between the Gross enrolment ratio (%) in Secondary schools in 2005 and the Gross enrolment ratio (%) in Tertiary schools in 2009?
Your response must be concise. -1.25. What is the difference between the Gross enrolment ratio (%) in Pre-primary schools in 2005 and the Gross enrolment ratio (%) in Primary schools in 2010?
Offer a very short reply. -91.26. What is the difference between the Gross enrolment ratio (%) of Pre-primary schools in 2005 and the Gross enrolment ratio (%) of Secondary schools in 2010?
Ensure brevity in your answer.  -8.22. What is the difference between the Gross enrolment ratio (%) in Pre-primary schools in 2005 and the Gross enrolment ratio (%) in Tertiary schools in 2010?
Your response must be concise. 2.01. What is the difference between the Gross enrolment ratio (%) in Primary schools in 2005 and the Gross enrolment ratio (%) in Secondary schools in 2010?
Give a very brief answer. 35.56. What is the difference between the Gross enrolment ratio (%) of Primary schools in 2005 and the Gross enrolment ratio (%) of Tertiary schools in 2010?
Provide a succinct answer. 45.79. What is the difference between the Gross enrolment ratio (%) in Secondary schools in 2005 and the Gross enrolment ratio (%) in Tertiary schools in 2010?
Provide a succinct answer. -1.89. What is the difference between the Gross enrolment ratio (%) in Pre-primary schools in 2006 and the Gross enrolment ratio (%) in Primary schools in 2008?
Provide a succinct answer. -69.88. What is the difference between the Gross enrolment ratio (%) in Pre-primary schools in 2006 and the Gross enrolment ratio (%) in Secondary schools in 2008?
Make the answer very short. 0.96. What is the difference between the Gross enrolment ratio (%) in Pre-primary schools in 2006 and the Gross enrolment ratio (%) in Tertiary schools in 2008?
Keep it short and to the point. 3.9. What is the difference between the Gross enrolment ratio (%) of Primary schools in 2006 and the Gross enrolment ratio (%) of Secondary schools in 2008?
Your answer should be very brief. 53.69. What is the difference between the Gross enrolment ratio (%) in Primary schools in 2006 and the Gross enrolment ratio (%) in Tertiary schools in 2008?
Make the answer very short. 56.64. What is the difference between the Gross enrolment ratio (%) in Secondary schools in 2006 and the Gross enrolment ratio (%) in Tertiary schools in 2008?
Ensure brevity in your answer.  0.29. What is the difference between the Gross enrolment ratio (%) of Pre-primary schools in 2006 and the Gross enrolment ratio (%) of Primary schools in 2009?
Provide a short and direct response. -85.12. What is the difference between the Gross enrolment ratio (%) of Pre-primary schools in 2006 and the Gross enrolment ratio (%) of Secondary schools in 2009?
Ensure brevity in your answer.  -3.13. What is the difference between the Gross enrolment ratio (%) in Pre-primary schools in 2006 and the Gross enrolment ratio (%) in Tertiary schools in 2009?
Give a very brief answer. 3.79. What is the difference between the Gross enrolment ratio (%) of Primary schools in 2006 and the Gross enrolment ratio (%) of Secondary schools in 2009?
Provide a succinct answer. 49.61. What is the difference between the Gross enrolment ratio (%) of Primary schools in 2006 and the Gross enrolment ratio (%) of Tertiary schools in 2009?
Your answer should be compact. 56.53. What is the difference between the Gross enrolment ratio (%) in Secondary schools in 2006 and the Gross enrolment ratio (%) in Tertiary schools in 2009?
Your answer should be compact. 0.18. What is the difference between the Gross enrolment ratio (%) in Pre-primary schools in 2006 and the Gross enrolment ratio (%) in Primary schools in 2010?
Your answer should be compact. -90.11. What is the difference between the Gross enrolment ratio (%) in Pre-primary schools in 2006 and the Gross enrolment ratio (%) in Secondary schools in 2010?
Provide a succinct answer. -7.07. What is the difference between the Gross enrolment ratio (%) of Pre-primary schools in 2006 and the Gross enrolment ratio (%) of Tertiary schools in 2010?
Give a very brief answer. 3.16. What is the difference between the Gross enrolment ratio (%) in Primary schools in 2006 and the Gross enrolment ratio (%) in Secondary schools in 2010?
Provide a short and direct response. 45.67. What is the difference between the Gross enrolment ratio (%) in Primary schools in 2006 and the Gross enrolment ratio (%) in Tertiary schools in 2010?
Keep it short and to the point. 55.89. What is the difference between the Gross enrolment ratio (%) of Secondary schools in 2006 and the Gross enrolment ratio (%) of Tertiary schools in 2010?
Keep it short and to the point. -0.46. What is the difference between the Gross enrolment ratio (%) in Pre-primary schools in 2008 and the Gross enrolment ratio (%) in Primary schools in 2009?
Provide a succinct answer. -88.41. What is the difference between the Gross enrolment ratio (%) of Pre-primary schools in 2008 and the Gross enrolment ratio (%) of Secondary schools in 2009?
Give a very brief answer. -6.42. What is the difference between the Gross enrolment ratio (%) of Pre-primary schools in 2008 and the Gross enrolment ratio (%) of Tertiary schools in 2009?
Ensure brevity in your answer.  0.5. What is the difference between the Gross enrolment ratio (%) of Primary schools in 2008 and the Gross enrolment ratio (%) of Secondary schools in 2009?
Your response must be concise. 66.75. What is the difference between the Gross enrolment ratio (%) of Primary schools in 2008 and the Gross enrolment ratio (%) of Tertiary schools in 2009?
Provide a short and direct response. 73.67. What is the difference between the Gross enrolment ratio (%) of Secondary schools in 2008 and the Gross enrolment ratio (%) of Tertiary schools in 2009?
Give a very brief answer. 2.83. What is the difference between the Gross enrolment ratio (%) of Pre-primary schools in 2008 and the Gross enrolment ratio (%) of Primary schools in 2010?
Provide a succinct answer. -93.4. What is the difference between the Gross enrolment ratio (%) in Pre-primary schools in 2008 and the Gross enrolment ratio (%) in Secondary schools in 2010?
Give a very brief answer. -10.36. What is the difference between the Gross enrolment ratio (%) of Pre-primary schools in 2008 and the Gross enrolment ratio (%) of Tertiary schools in 2010?
Ensure brevity in your answer.  -0.13. What is the difference between the Gross enrolment ratio (%) of Primary schools in 2008 and the Gross enrolment ratio (%) of Secondary schools in 2010?
Your response must be concise. 62.81. What is the difference between the Gross enrolment ratio (%) in Primary schools in 2008 and the Gross enrolment ratio (%) in Tertiary schools in 2010?
Offer a terse response. 73.04. What is the difference between the Gross enrolment ratio (%) of Secondary schools in 2008 and the Gross enrolment ratio (%) of Tertiary schools in 2010?
Your response must be concise. 2.2. What is the difference between the Gross enrolment ratio (%) of Pre-primary schools in 2009 and the Gross enrolment ratio (%) of Primary schools in 2010?
Provide a succinct answer. -91.3. What is the difference between the Gross enrolment ratio (%) in Pre-primary schools in 2009 and the Gross enrolment ratio (%) in Secondary schools in 2010?
Offer a terse response. -8.26. What is the difference between the Gross enrolment ratio (%) of Pre-primary schools in 2009 and the Gross enrolment ratio (%) of Tertiary schools in 2010?
Give a very brief answer. 1.97. What is the difference between the Gross enrolment ratio (%) in Primary schools in 2009 and the Gross enrolment ratio (%) in Secondary schools in 2010?
Your answer should be very brief. 78.05. What is the difference between the Gross enrolment ratio (%) of Primary schools in 2009 and the Gross enrolment ratio (%) of Tertiary schools in 2010?
Offer a very short reply. 88.28. What is the difference between the Gross enrolment ratio (%) of Secondary schools in 2009 and the Gross enrolment ratio (%) of Tertiary schools in 2010?
Offer a terse response. 6.28. What is the average Gross enrolment ratio (%) of Pre-primary schools per year?
Your answer should be very brief. 12.78. What is the average Gross enrolment ratio (%) of Primary schools per year?
Your answer should be very brief. 71.07. What is the average Gross enrolment ratio (%) in Secondary schools per year?
Your answer should be very brief. 11.54. What is the average Gross enrolment ratio (%) of Tertiary schools per year?
Provide a succinct answer. 7.61. In the year 2001, what is the difference between the Gross enrolment ratio (%) of Pre-primary schools and Gross enrolment ratio (%) of Primary schools?
Offer a terse response. -42.53. In the year 2001, what is the difference between the Gross enrolment ratio (%) in Pre-primary schools and Gross enrolment ratio (%) in Secondary schools?
Provide a succinct answer. 2.45. In the year 2001, what is the difference between the Gross enrolment ratio (%) in Pre-primary schools and Gross enrolment ratio (%) in Tertiary schools?
Provide a succinct answer. 3.43. In the year 2001, what is the difference between the Gross enrolment ratio (%) in Primary schools and Gross enrolment ratio (%) in Secondary schools?
Your response must be concise. 44.98. In the year 2001, what is the difference between the Gross enrolment ratio (%) in Primary schools and Gross enrolment ratio (%) in Tertiary schools?
Provide a short and direct response. 45.95. In the year 2001, what is the difference between the Gross enrolment ratio (%) in Secondary schools and Gross enrolment ratio (%) in Tertiary schools?
Offer a terse response. 0.97. In the year 2002, what is the difference between the Gross enrolment ratio (%) of Pre-primary schools and Gross enrolment ratio (%) of Primary schools?
Offer a very short reply. -42.01. In the year 2002, what is the difference between the Gross enrolment ratio (%) in Pre-primary schools and Gross enrolment ratio (%) in Secondary schools?
Offer a very short reply. 5.55. In the year 2002, what is the difference between the Gross enrolment ratio (%) of Pre-primary schools and Gross enrolment ratio (%) of Tertiary schools?
Offer a very short reply. 6.82. In the year 2002, what is the difference between the Gross enrolment ratio (%) of Primary schools and Gross enrolment ratio (%) of Secondary schools?
Make the answer very short. 47.56. In the year 2002, what is the difference between the Gross enrolment ratio (%) in Primary schools and Gross enrolment ratio (%) in Tertiary schools?
Provide a short and direct response. 48.83. In the year 2002, what is the difference between the Gross enrolment ratio (%) of Secondary schools and Gross enrolment ratio (%) of Tertiary schools?
Give a very brief answer. 1.27. In the year 2003, what is the difference between the Gross enrolment ratio (%) in Pre-primary schools and Gross enrolment ratio (%) in Primary schools?
Provide a succinct answer. -46.84. In the year 2003, what is the difference between the Gross enrolment ratio (%) in Pre-primary schools and Gross enrolment ratio (%) in Secondary schools?
Offer a very short reply. 4.6. In the year 2003, what is the difference between the Gross enrolment ratio (%) of Pre-primary schools and Gross enrolment ratio (%) of Tertiary schools?
Make the answer very short. 6.77. In the year 2003, what is the difference between the Gross enrolment ratio (%) in Primary schools and Gross enrolment ratio (%) in Secondary schools?
Ensure brevity in your answer.  51.44. In the year 2003, what is the difference between the Gross enrolment ratio (%) of Primary schools and Gross enrolment ratio (%) of Tertiary schools?
Offer a very short reply. 53.61. In the year 2003, what is the difference between the Gross enrolment ratio (%) of Secondary schools and Gross enrolment ratio (%) of Tertiary schools?
Ensure brevity in your answer.  2.17. In the year 2004, what is the difference between the Gross enrolment ratio (%) in Pre-primary schools and Gross enrolment ratio (%) in Primary schools?
Your response must be concise. -45.42. In the year 2004, what is the difference between the Gross enrolment ratio (%) of Pre-primary schools and Gross enrolment ratio (%) of Secondary schools?
Your answer should be compact. 6.49. In the year 2004, what is the difference between the Gross enrolment ratio (%) of Pre-primary schools and Gross enrolment ratio (%) of Tertiary schools?
Keep it short and to the point. 8.47. In the year 2004, what is the difference between the Gross enrolment ratio (%) in Primary schools and Gross enrolment ratio (%) in Secondary schools?
Make the answer very short. 51.91. In the year 2004, what is the difference between the Gross enrolment ratio (%) in Primary schools and Gross enrolment ratio (%) in Tertiary schools?
Make the answer very short. 53.89. In the year 2004, what is the difference between the Gross enrolment ratio (%) in Secondary schools and Gross enrolment ratio (%) in Tertiary schools?
Provide a succinct answer. 1.98. In the year 2005, what is the difference between the Gross enrolment ratio (%) of Pre-primary schools and Gross enrolment ratio (%) of Primary schools?
Your answer should be compact. -43.78. In the year 2005, what is the difference between the Gross enrolment ratio (%) in Pre-primary schools and Gross enrolment ratio (%) in Secondary schools?
Your response must be concise. 3.9. In the year 2005, what is the difference between the Gross enrolment ratio (%) of Pre-primary schools and Gross enrolment ratio (%) of Tertiary schools?
Give a very brief answer. 7.91. In the year 2005, what is the difference between the Gross enrolment ratio (%) in Primary schools and Gross enrolment ratio (%) in Secondary schools?
Provide a short and direct response. 47.68. In the year 2005, what is the difference between the Gross enrolment ratio (%) in Primary schools and Gross enrolment ratio (%) in Tertiary schools?
Give a very brief answer. 51.7. In the year 2005, what is the difference between the Gross enrolment ratio (%) in Secondary schools and Gross enrolment ratio (%) in Tertiary schools?
Offer a terse response. 4.01. In the year 2006, what is the difference between the Gross enrolment ratio (%) of Pre-primary schools and Gross enrolment ratio (%) of Primary schools?
Give a very brief answer. -52.73. In the year 2006, what is the difference between the Gross enrolment ratio (%) in Pre-primary schools and Gross enrolment ratio (%) in Secondary schools?
Keep it short and to the point. 3.61. In the year 2006, what is the difference between the Gross enrolment ratio (%) of Pre-primary schools and Gross enrolment ratio (%) of Tertiary schools?
Give a very brief answer. 8.45. In the year 2006, what is the difference between the Gross enrolment ratio (%) in Primary schools and Gross enrolment ratio (%) in Secondary schools?
Give a very brief answer. 56.35. In the year 2006, what is the difference between the Gross enrolment ratio (%) in Primary schools and Gross enrolment ratio (%) in Tertiary schools?
Ensure brevity in your answer.  61.19. In the year 2006, what is the difference between the Gross enrolment ratio (%) in Secondary schools and Gross enrolment ratio (%) in Tertiary schools?
Provide a succinct answer. 4.84. In the year 2008, what is the difference between the Gross enrolment ratio (%) in Pre-primary schools and Gross enrolment ratio (%) in Primary schools?
Provide a succinct answer. -73.17. In the year 2008, what is the difference between the Gross enrolment ratio (%) in Pre-primary schools and Gross enrolment ratio (%) in Secondary schools?
Offer a terse response. -2.33. In the year 2008, what is the difference between the Gross enrolment ratio (%) of Pre-primary schools and Gross enrolment ratio (%) of Tertiary schools?
Provide a short and direct response. 0.61. In the year 2008, what is the difference between the Gross enrolment ratio (%) of Primary schools and Gross enrolment ratio (%) of Secondary schools?
Provide a succinct answer. 70.84. In the year 2008, what is the difference between the Gross enrolment ratio (%) in Primary schools and Gross enrolment ratio (%) in Tertiary schools?
Provide a succinct answer. 73.78. In the year 2008, what is the difference between the Gross enrolment ratio (%) of Secondary schools and Gross enrolment ratio (%) of Tertiary schools?
Give a very brief answer. 2.94. In the year 2009, what is the difference between the Gross enrolment ratio (%) of Pre-primary schools and Gross enrolment ratio (%) of Primary schools?
Provide a short and direct response. -86.31. In the year 2009, what is the difference between the Gross enrolment ratio (%) of Pre-primary schools and Gross enrolment ratio (%) of Secondary schools?
Offer a very short reply. -4.32. In the year 2009, what is the difference between the Gross enrolment ratio (%) in Pre-primary schools and Gross enrolment ratio (%) in Tertiary schools?
Ensure brevity in your answer.  2.6. In the year 2009, what is the difference between the Gross enrolment ratio (%) of Primary schools and Gross enrolment ratio (%) of Secondary schools?
Offer a terse response. 82. In the year 2009, what is the difference between the Gross enrolment ratio (%) in Primary schools and Gross enrolment ratio (%) in Tertiary schools?
Offer a terse response. 88.92. In the year 2009, what is the difference between the Gross enrolment ratio (%) of Secondary schools and Gross enrolment ratio (%) of Tertiary schools?
Make the answer very short. 6.92. In the year 2010, what is the difference between the Gross enrolment ratio (%) in Pre-primary schools and Gross enrolment ratio (%) in Primary schools?
Give a very brief answer. -91.86. In the year 2010, what is the difference between the Gross enrolment ratio (%) in Pre-primary schools and Gross enrolment ratio (%) in Secondary schools?
Your answer should be very brief. -8.82. In the year 2010, what is the difference between the Gross enrolment ratio (%) in Pre-primary schools and Gross enrolment ratio (%) in Tertiary schools?
Keep it short and to the point. 1.41. In the year 2010, what is the difference between the Gross enrolment ratio (%) of Primary schools and Gross enrolment ratio (%) of Secondary schools?
Your answer should be very brief. 83.04. In the year 2010, what is the difference between the Gross enrolment ratio (%) of Primary schools and Gross enrolment ratio (%) of Tertiary schools?
Offer a terse response. 93.27. In the year 2010, what is the difference between the Gross enrolment ratio (%) in Secondary schools and Gross enrolment ratio (%) in Tertiary schools?
Your answer should be compact. 10.23. What is the ratio of the Gross enrolment ratio (%) of Pre-primary schools in 2001 to that in 2002?
Ensure brevity in your answer.  0.7. What is the ratio of the Gross enrolment ratio (%) of Primary schools in 2001 to that in 2002?
Provide a short and direct response. 0.94. What is the ratio of the Gross enrolment ratio (%) in Secondary schools in 2001 to that in 2002?
Offer a very short reply. 0.93. What is the ratio of the Gross enrolment ratio (%) of Tertiary schools in 2001 to that in 2002?
Offer a very short reply. 0.97. What is the ratio of the Gross enrolment ratio (%) in Pre-primary schools in 2001 to that in 2003?
Ensure brevity in your answer.  0.72. What is the ratio of the Gross enrolment ratio (%) in Primary schools in 2001 to that in 2003?
Ensure brevity in your answer.  0.87. What is the ratio of the Gross enrolment ratio (%) in Secondary schools in 2001 to that in 2003?
Make the answer very short. 0.84. What is the ratio of the Gross enrolment ratio (%) in Tertiary schools in 2001 to that in 2003?
Offer a terse response. 1.01. What is the ratio of the Gross enrolment ratio (%) of Pre-primary schools in 2001 to that in 2004?
Make the answer very short. 0.59. What is the ratio of the Gross enrolment ratio (%) in Primary schools in 2001 to that in 2004?
Your response must be concise. 0.85. What is the ratio of the Gross enrolment ratio (%) of Secondary schools in 2001 to that in 2004?
Ensure brevity in your answer.  0.77. What is the ratio of the Gross enrolment ratio (%) of Tertiary schools in 2001 to that in 2004?
Your answer should be compact. 0.87. What is the ratio of the Gross enrolment ratio (%) in Pre-primary schools in 2001 to that in 2005?
Provide a short and direct response. 0.6. What is the ratio of the Gross enrolment ratio (%) of Secondary schools in 2001 to that in 2005?
Provide a succinct answer. 0.58. What is the ratio of the Gross enrolment ratio (%) in Tertiary schools in 2001 to that in 2005?
Ensure brevity in your answer.  0.81. What is the ratio of the Gross enrolment ratio (%) of Pre-primary schools in 2001 to that in 2006?
Keep it short and to the point. 0.55. What is the ratio of the Gross enrolment ratio (%) in Primary schools in 2001 to that in 2006?
Offer a very short reply. 0.75. What is the ratio of the Gross enrolment ratio (%) in Secondary schools in 2001 to that in 2006?
Provide a short and direct response. 0.51. What is the ratio of the Gross enrolment ratio (%) of Tertiary schools in 2001 to that in 2006?
Your answer should be compact. 0.73. What is the ratio of the Gross enrolment ratio (%) in Pre-primary schools in 2001 to that in 2008?
Your answer should be very brief. 0.7. What is the ratio of the Gross enrolment ratio (%) of Primary schools in 2001 to that in 2008?
Offer a terse response. 0.6. What is the ratio of the Gross enrolment ratio (%) of Secondary schools in 2001 to that in 2008?
Provide a succinct answer. 0.42. What is the ratio of the Gross enrolment ratio (%) in Tertiary schools in 2001 to that in 2008?
Your response must be concise. 0.44. What is the ratio of the Gross enrolment ratio (%) of Pre-primary schools in 2001 to that in 2009?
Provide a short and direct response. 0.6. What is the ratio of the Gross enrolment ratio (%) in Primary schools in 2001 to that in 2009?
Keep it short and to the point. 0.51. What is the ratio of the Gross enrolment ratio (%) in Secondary schools in 2001 to that in 2009?
Your answer should be compact. 0.32. What is the ratio of the Gross enrolment ratio (%) in Tertiary schools in 2001 to that in 2009?
Your answer should be very brief. 0.43. What is the ratio of the Gross enrolment ratio (%) of Pre-primary schools in 2001 to that in 2010?
Offer a very short reply. 0.62. What is the ratio of the Gross enrolment ratio (%) in Primary schools in 2001 to that in 2010?
Offer a terse response. 0.48. What is the ratio of the Gross enrolment ratio (%) of Secondary schools in 2001 to that in 2010?
Ensure brevity in your answer.  0.27. What is the ratio of the Gross enrolment ratio (%) in Tertiary schools in 2001 to that in 2010?
Offer a terse response. 0.41. What is the ratio of the Gross enrolment ratio (%) in Pre-primary schools in 2002 to that in 2003?
Your answer should be very brief. 1.02. What is the ratio of the Gross enrolment ratio (%) in Primary schools in 2002 to that in 2003?
Keep it short and to the point. 0.92. What is the ratio of the Gross enrolment ratio (%) in Secondary schools in 2002 to that in 2003?
Your answer should be very brief. 0.9. What is the ratio of the Gross enrolment ratio (%) of Tertiary schools in 2002 to that in 2003?
Your answer should be compact. 1.04. What is the ratio of the Gross enrolment ratio (%) of Pre-primary schools in 2002 to that in 2004?
Your answer should be very brief. 0.84. What is the ratio of the Gross enrolment ratio (%) in Primary schools in 2002 to that in 2004?
Ensure brevity in your answer.  0.91. What is the ratio of the Gross enrolment ratio (%) of Secondary schools in 2002 to that in 2004?
Your answer should be compact. 0.84. What is the ratio of the Gross enrolment ratio (%) of Tertiary schools in 2002 to that in 2004?
Your answer should be very brief. 0.9. What is the ratio of the Gross enrolment ratio (%) of Pre-primary schools in 2002 to that in 2005?
Your answer should be very brief. 0.85. What is the ratio of the Gross enrolment ratio (%) in Primary schools in 2002 to that in 2005?
Offer a very short reply. 0.93. What is the ratio of the Gross enrolment ratio (%) in Secondary schools in 2002 to that in 2005?
Your answer should be very brief. 0.63. What is the ratio of the Gross enrolment ratio (%) in Tertiary schools in 2002 to that in 2005?
Your response must be concise. 0.83. What is the ratio of the Gross enrolment ratio (%) of Pre-primary schools in 2002 to that in 2006?
Your answer should be very brief. 0.79. What is the ratio of the Gross enrolment ratio (%) in Primary schools in 2002 to that in 2006?
Provide a short and direct response. 0.79. What is the ratio of the Gross enrolment ratio (%) of Secondary schools in 2002 to that in 2006?
Give a very brief answer. 0.55. What is the ratio of the Gross enrolment ratio (%) in Tertiary schools in 2002 to that in 2006?
Offer a very short reply. 0.76. What is the ratio of the Gross enrolment ratio (%) of Primary schools in 2002 to that in 2008?
Give a very brief answer. 0.63. What is the ratio of the Gross enrolment ratio (%) of Secondary schools in 2002 to that in 2008?
Your answer should be very brief. 0.45. What is the ratio of the Gross enrolment ratio (%) in Tertiary schools in 2002 to that in 2008?
Offer a terse response. 0.45. What is the ratio of the Gross enrolment ratio (%) in Pre-primary schools in 2002 to that in 2009?
Offer a very short reply. 0.85. What is the ratio of the Gross enrolment ratio (%) in Primary schools in 2002 to that in 2009?
Ensure brevity in your answer.  0.54. What is the ratio of the Gross enrolment ratio (%) in Secondary schools in 2002 to that in 2009?
Make the answer very short. 0.35. What is the ratio of the Gross enrolment ratio (%) of Tertiary schools in 2002 to that in 2009?
Make the answer very short. 0.45. What is the ratio of the Gross enrolment ratio (%) in Pre-primary schools in 2002 to that in 2010?
Make the answer very short. 0.89. What is the ratio of the Gross enrolment ratio (%) in Primary schools in 2002 to that in 2010?
Ensure brevity in your answer.  0.51. What is the ratio of the Gross enrolment ratio (%) in Secondary schools in 2002 to that in 2010?
Provide a succinct answer. 0.29. What is the ratio of the Gross enrolment ratio (%) of Tertiary schools in 2002 to that in 2010?
Your response must be concise. 0.43. What is the ratio of the Gross enrolment ratio (%) in Pre-primary schools in 2003 to that in 2004?
Your response must be concise. 0.83. What is the ratio of the Gross enrolment ratio (%) in Primary schools in 2003 to that in 2004?
Give a very brief answer. 0.98. What is the ratio of the Gross enrolment ratio (%) in Secondary schools in 2003 to that in 2004?
Make the answer very short. 0.93. What is the ratio of the Gross enrolment ratio (%) in Tertiary schools in 2003 to that in 2004?
Give a very brief answer. 0.87. What is the ratio of the Gross enrolment ratio (%) in Pre-primary schools in 2003 to that in 2005?
Offer a very short reply. 0.83. What is the ratio of the Gross enrolment ratio (%) in Primary schools in 2003 to that in 2005?
Keep it short and to the point. 1.01. What is the ratio of the Gross enrolment ratio (%) in Secondary schools in 2003 to that in 2005?
Provide a short and direct response. 0.7. What is the ratio of the Gross enrolment ratio (%) in Tertiary schools in 2003 to that in 2005?
Offer a very short reply. 0.8. What is the ratio of the Gross enrolment ratio (%) of Pre-primary schools in 2003 to that in 2006?
Keep it short and to the point. 0.77. What is the ratio of the Gross enrolment ratio (%) of Primary schools in 2003 to that in 2006?
Your answer should be compact. 0.86. What is the ratio of the Gross enrolment ratio (%) in Secondary schools in 2003 to that in 2006?
Give a very brief answer. 0.61. What is the ratio of the Gross enrolment ratio (%) of Tertiary schools in 2003 to that in 2006?
Your response must be concise. 0.73. What is the ratio of the Gross enrolment ratio (%) of Pre-primary schools in 2003 to that in 2008?
Provide a short and direct response. 0.98. What is the ratio of the Gross enrolment ratio (%) in Primary schools in 2003 to that in 2008?
Offer a very short reply. 0.69. What is the ratio of the Gross enrolment ratio (%) in Secondary schools in 2003 to that in 2008?
Provide a succinct answer. 0.5. What is the ratio of the Gross enrolment ratio (%) in Tertiary schools in 2003 to that in 2008?
Your response must be concise. 0.44. What is the ratio of the Gross enrolment ratio (%) of Pre-primary schools in 2003 to that in 2009?
Provide a succinct answer. 0.83. What is the ratio of the Gross enrolment ratio (%) of Primary schools in 2003 to that in 2009?
Offer a terse response. 0.58. What is the ratio of the Gross enrolment ratio (%) in Secondary schools in 2003 to that in 2009?
Give a very brief answer. 0.39. What is the ratio of the Gross enrolment ratio (%) in Tertiary schools in 2003 to that in 2009?
Your answer should be very brief. 0.43. What is the ratio of the Gross enrolment ratio (%) of Pre-primary schools in 2003 to that in 2010?
Offer a very short reply. 0.87. What is the ratio of the Gross enrolment ratio (%) of Primary schools in 2003 to that in 2010?
Your answer should be compact. 0.56. What is the ratio of the Gross enrolment ratio (%) in Secondary schools in 2003 to that in 2010?
Your response must be concise. 0.32. What is the ratio of the Gross enrolment ratio (%) in Tertiary schools in 2003 to that in 2010?
Your answer should be very brief. 0.41. What is the ratio of the Gross enrolment ratio (%) in Primary schools in 2004 to that in 2005?
Your response must be concise. 1.03. What is the ratio of the Gross enrolment ratio (%) in Secondary schools in 2004 to that in 2005?
Your response must be concise. 0.75. What is the ratio of the Gross enrolment ratio (%) of Tertiary schools in 2004 to that in 2005?
Provide a succinct answer. 0.92. What is the ratio of the Gross enrolment ratio (%) of Pre-primary schools in 2004 to that in 2006?
Provide a short and direct response. 0.93. What is the ratio of the Gross enrolment ratio (%) in Primary schools in 2004 to that in 2006?
Make the answer very short. 0.88. What is the ratio of the Gross enrolment ratio (%) in Secondary schools in 2004 to that in 2006?
Make the answer very short. 0.66. What is the ratio of the Gross enrolment ratio (%) of Tertiary schools in 2004 to that in 2006?
Provide a succinct answer. 0.84. What is the ratio of the Gross enrolment ratio (%) in Pre-primary schools in 2004 to that in 2008?
Offer a very short reply. 1.19. What is the ratio of the Gross enrolment ratio (%) in Primary schools in 2004 to that in 2008?
Provide a short and direct response. 0.7. What is the ratio of the Gross enrolment ratio (%) in Secondary schools in 2004 to that in 2008?
Your response must be concise. 0.54. What is the ratio of the Gross enrolment ratio (%) in Tertiary schools in 2004 to that in 2008?
Your response must be concise. 0.5. What is the ratio of the Gross enrolment ratio (%) in Pre-primary schools in 2004 to that in 2009?
Make the answer very short. 1.01. What is the ratio of the Gross enrolment ratio (%) of Primary schools in 2004 to that in 2009?
Make the answer very short. 0.59. What is the ratio of the Gross enrolment ratio (%) of Secondary schools in 2004 to that in 2009?
Your response must be concise. 0.42. What is the ratio of the Gross enrolment ratio (%) in Tertiary schools in 2004 to that in 2009?
Keep it short and to the point. 0.5. What is the ratio of the Gross enrolment ratio (%) of Pre-primary schools in 2004 to that in 2010?
Make the answer very short. 1.05. What is the ratio of the Gross enrolment ratio (%) in Primary schools in 2004 to that in 2010?
Give a very brief answer. 0.57. What is the ratio of the Gross enrolment ratio (%) of Secondary schools in 2004 to that in 2010?
Give a very brief answer. 0.34. What is the ratio of the Gross enrolment ratio (%) of Tertiary schools in 2004 to that in 2010?
Ensure brevity in your answer.  0.47. What is the ratio of the Gross enrolment ratio (%) in Pre-primary schools in 2005 to that in 2006?
Offer a terse response. 0.92. What is the ratio of the Gross enrolment ratio (%) of Primary schools in 2005 to that in 2006?
Provide a succinct answer. 0.85. What is the ratio of the Gross enrolment ratio (%) in Secondary schools in 2005 to that in 2006?
Your answer should be very brief. 0.88. What is the ratio of the Gross enrolment ratio (%) in Tertiary schools in 2005 to that in 2006?
Offer a very short reply. 0.91. What is the ratio of the Gross enrolment ratio (%) in Pre-primary schools in 2005 to that in 2008?
Keep it short and to the point. 1.18. What is the ratio of the Gross enrolment ratio (%) of Primary schools in 2005 to that in 2008?
Offer a terse response. 0.68. What is the ratio of the Gross enrolment ratio (%) in Secondary schools in 2005 to that in 2008?
Your answer should be compact. 0.71. What is the ratio of the Gross enrolment ratio (%) of Tertiary schools in 2005 to that in 2008?
Ensure brevity in your answer.  0.54. What is the ratio of the Gross enrolment ratio (%) of Primary schools in 2005 to that in 2009?
Your response must be concise. 0.58. What is the ratio of the Gross enrolment ratio (%) of Secondary schools in 2005 to that in 2009?
Provide a succinct answer. 0.55. What is the ratio of the Gross enrolment ratio (%) in Tertiary schools in 2005 to that in 2009?
Your response must be concise. 0.54. What is the ratio of the Gross enrolment ratio (%) of Pre-primary schools in 2005 to that in 2010?
Offer a very short reply. 1.04. What is the ratio of the Gross enrolment ratio (%) of Primary schools in 2005 to that in 2010?
Keep it short and to the point. 0.55. What is the ratio of the Gross enrolment ratio (%) in Secondary schools in 2005 to that in 2010?
Your answer should be very brief. 0.46. What is the ratio of the Gross enrolment ratio (%) of Tertiary schools in 2005 to that in 2010?
Provide a succinct answer. 0.51. What is the ratio of the Gross enrolment ratio (%) in Pre-primary schools in 2006 to that in 2008?
Make the answer very short. 1.28. What is the ratio of the Gross enrolment ratio (%) in Primary schools in 2006 to that in 2008?
Your answer should be very brief. 0.8. What is the ratio of the Gross enrolment ratio (%) of Secondary schools in 2006 to that in 2008?
Offer a very short reply. 0.81. What is the ratio of the Gross enrolment ratio (%) of Tertiary schools in 2006 to that in 2008?
Your answer should be compact. 0.6. What is the ratio of the Gross enrolment ratio (%) in Pre-primary schools in 2006 to that in 2009?
Your answer should be compact. 1.08. What is the ratio of the Gross enrolment ratio (%) of Primary schools in 2006 to that in 2009?
Your answer should be very brief. 0.68. What is the ratio of the Gross enrolment ratio (%) of Secondary schools in 2006 to that in 2009?
Make the answer very short. 0.63. What is the ratio of the Gross enrolment ratio (%) in Tertiary schools in 2006 to that in 2009?
Make the answer very short. 0.59. What is the ratio of the Gross enrolment ratio (%) of Pre-primary schools in 2006 to that in 2010?
Provide a short and direct response. 1.13. What is the ratio of the Gross enrolment ratio (%) of Primary schools in 2006 to that in 2010?
Your answer should be compact. 0.65. What is the ratio of the Gross enrolment ratio (%) in Secondary schools in 2006 to that in 2010?
Provide a succinct answer. 0.52. What is the ratio of the Gross enrolment ratio (%) of Tertiary schools in 2006 to that in 2010?
Provide a short and direct response. 0.56. What is the ratio of the Gross enrolment ratio (%) in Pre-primary schools in 2008 to that in 2009?
Provide a short and direct response. 0.85. What is the ratio of the Gross enrolment ratio (%) of Primary schools in 2008 to that in 2009?
Provide a short and direct response. 0.85. What is the ratio of the Gross enrolment ratio (%) in Secondary schools in 2008 to that in 2009?
Your answer should be very brief. 0.78. What is the ratio of the Gross enrolment ratio (%) of Pre-primary schools in 2008 to that in 2010?
Your response must be concise. 0.89. What is the ratio of the Gross enrolment ratio (%) in Primary schools in 2008 to that in 2010?
Ensure brevity in your answer.  0.81. What is the ratio of the Gross enrolment ratio (%) in Secondary schools in 2008 to that in 2010?
Your answer should be compact. 0.64. What is the ratio of the Gross enrolment ratio (%) in Tertiary schools in 2008 to that in 2010?
Your answer should be very brief. 0.94. What is the ratio of the Gross enrolment ratio (%) of Pre-primary schools in 2009 to that in 2010?
Provide a short and direct response. 1.04. What is the ratio of the Gross enrolment ratio (%) in Primary schools in 2009 to that in 2010?
Keep it short and to the point. 0.95. What is the ratio of the Gross enrolment ratio (%) in Secondary schools in 2009 to that in 2010?
Provide a succinct answer. 0.82. What is the ratio of the Gross enrolment ratio (%) in Tertiary schools in 2009 to that in 2010?
Provide a short and direct response. 0.95. What is the difference between the highest and the second highest Gross enrolment ratio (%) of Pre-primary schools?
Make the answer very short. 1.06. What is the difference between the highest and the second highest Gross enrolment ratio (%) in Primary schools?
Offer a very short reply. 4.99. What is the difference between the highest and the second highest Gross enrolment ratio (%) in Secondary schools?
Make the answer very short. 3.94. What is the difference between the highest and the second highest Gross enrolment ratio (%) in Tertiary schools?
Your response must be concise. 0.64. What is the difference between the highest and the lowest Gross enrolment ratio (%) in Pre-primary schools?
Offer a terse response. 6.84. What is the difference between the highest and the lowest Gross enrolment ratio (%) of Primary schools?
Provide a succinct answer. 54.42. What is the difference between the highest and the lowest Gross enrolment ratio (%) in Secondary schools?
Offer a very short reply. 16.36. What is the difference between the highest and the lowest Gross enrolment ratio (%) in Tertiary schools?
Ensure brevity in your answer.  7.14. 